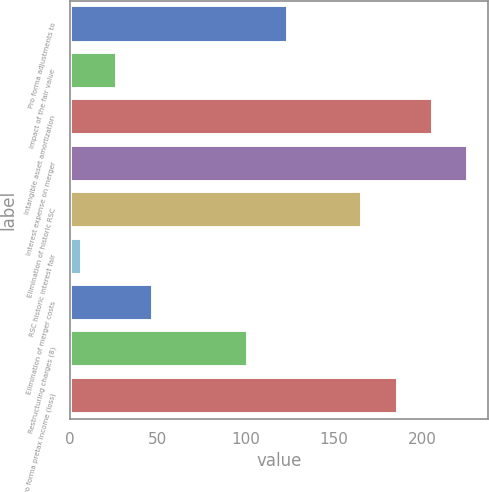<chart> <loc_0><loc_0><loc_500><loc_500><bar_chart><fcel>Pro forma adjustments to<fcel>Impact of the fair value<fcel>Intangible asset amortization<fcel>Interest expense on merger<fcel>Elimination of historic RSC<fcel>RSC historic interest fair<fcel>Elimination of merger costs<fcel>Restructuring charges (8)<fcel>Pro forma pretax income (loss)<nl><fcel>124<fcel>27<fcel>206<fcel>226<fcel>166<fcel>7<fcel>47<fcel>101<fcel>186<nl></chart> 